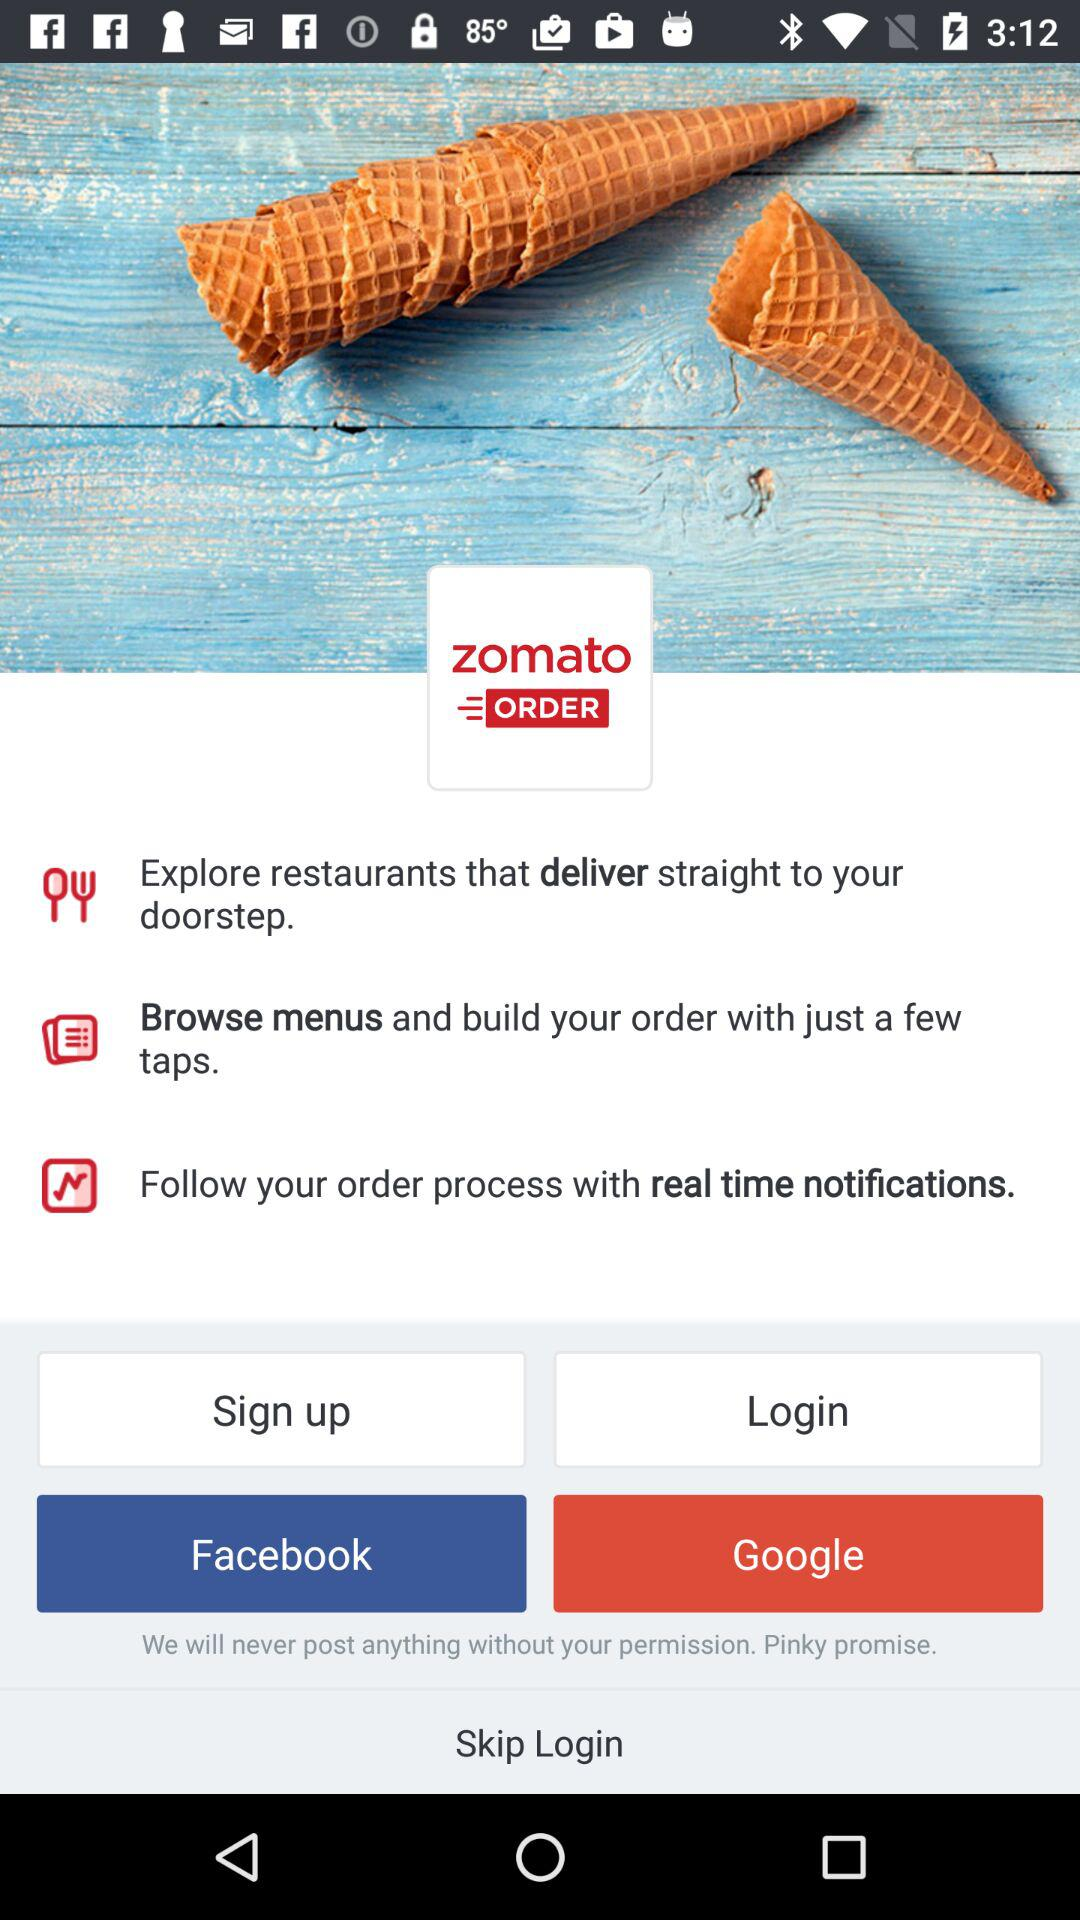What is the option to sign up? The options to sign up are "Facebook" and "Google". 